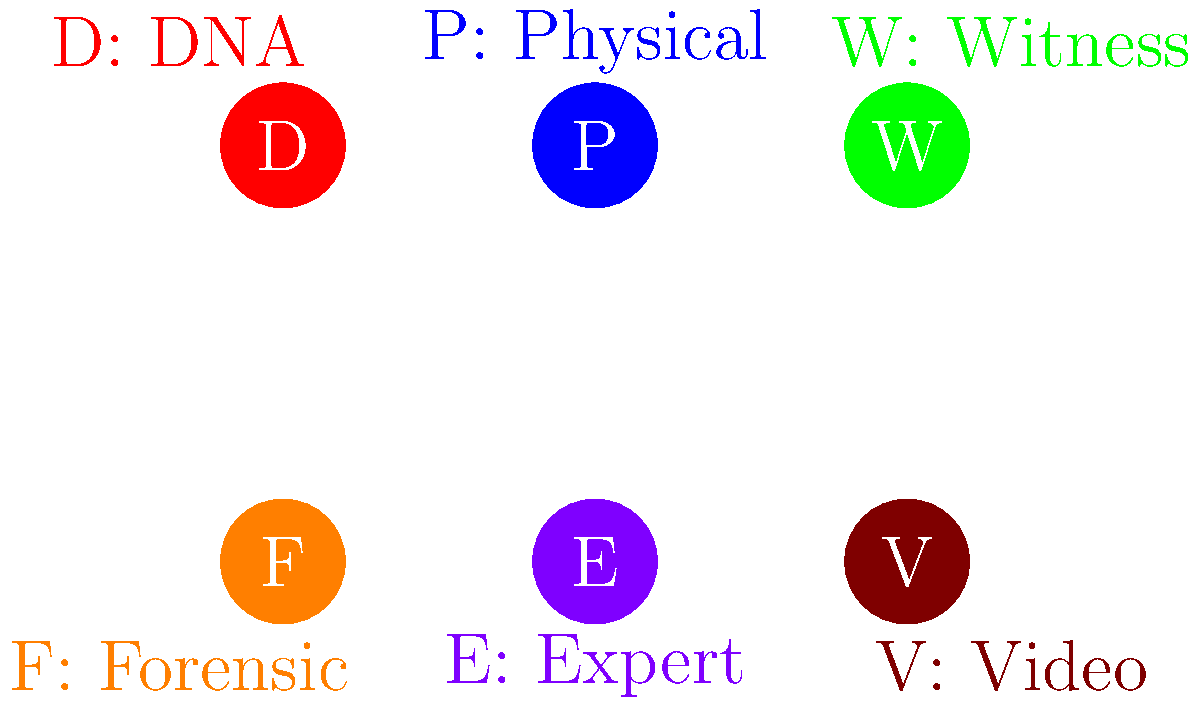In your recent trial, which type of evidence played the most crucial role in your acquittal, considering its reliability and impact on the jury? To answer this question, let's consider each type of evidence presented in the diagram and its potential impact on a trial:

1. DNA Evidence (D): Highly reliable and often considered the gold standard in forensic science. It can definitively link or exclude a suspect from a crime scene.

2. Physical Evidence (P): Tangible items found at the crime scene or linked to the crime. Their impact depends on their relevance and condition.

3. Witness Testimony (W): Can be powerful but is subject to human error, bias, or unreliability.

4. Forensic Evidence (F): Scientific analysis of physical evidence, which can provide strong support for a case but may be complex for juries to understand.

5. Expert Testimony (E): Can provide specialized knowledge to interpret evidence but may be seen as less objective than physical evidence.

6. Video Evidence (V): Can provide clear visual proof of events but may be subject to interpretation or quality issues.

In most cases, DNA evidence (D) is considered the most reliable and impactful type of evidence in a trial. It's scientifically based, highly accurate, and can directly link a person to a crime scene or exonerate them. DNA evidence is often seen as nearly irrefutable by juries, making it a powerful tool for both prosecution and defense.

For an acquitted defendant, DNA evidence that excludes them from the crime scene or contradicts the prosecution's theory would be extremely powerful. It could provide clear, scientific proof of innocence that's difficult for a jury to ignore.

While other types of evidence can be crucial depending on the specific case, DNA evidence generally holds the most weight due to its scientific reliability and perceived objectivity.
Answer: DNA evidence 